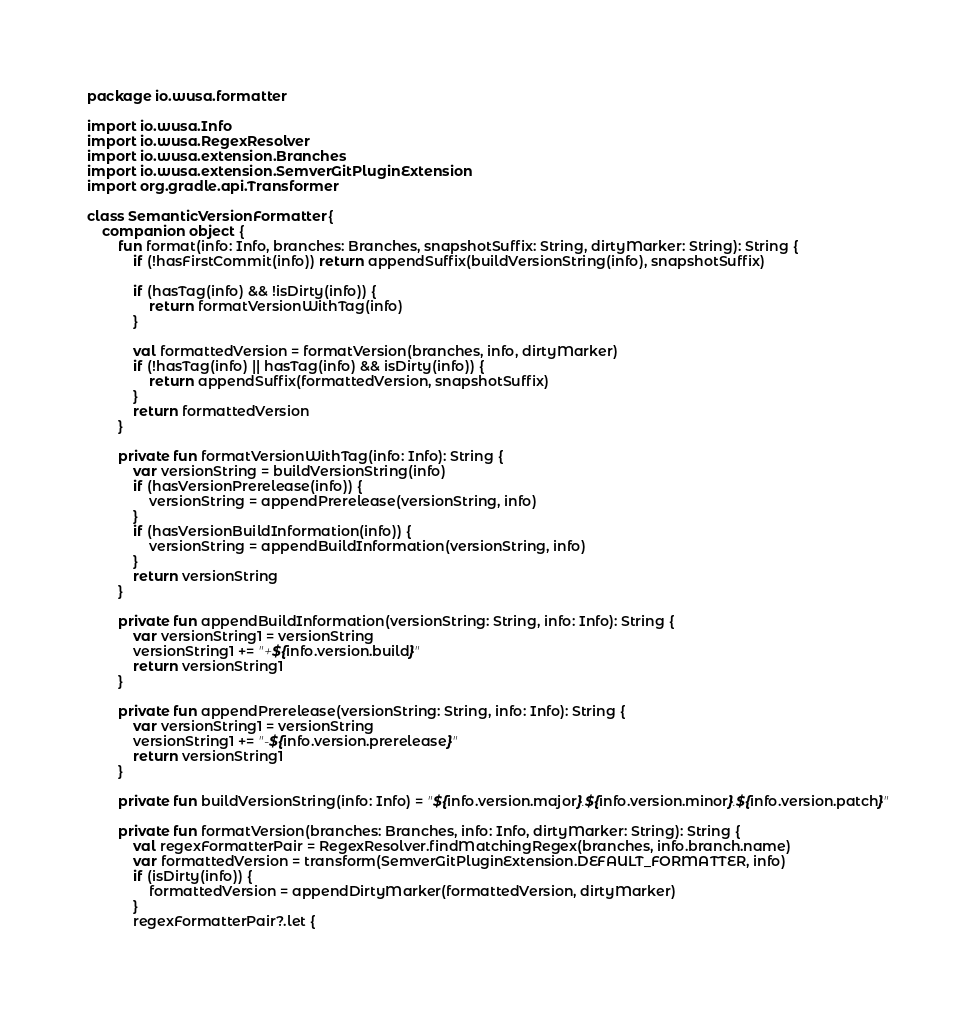Convert code to text. <code><loc_0><loc_0><loc_500><loc_500><_Kotlin_>package io.wusa.formatter

import io.wusa.Info
import io.wusa.RegexResolver
import io.wusa.extension.Branches
import io.wusa.extension.SemverGitPluginExtension
import org.gradle.api.Transformer

class SemanticVersionFormatter {
    companion object {
        fun format(info: Info, branches: Branches, snapshotSuffix: String, dirtyMarker: String): String {
            if (!hasFirstCommit(info)) return appendSuffix(buildVersionString(info), snapshotSuffix)

            if (hasTag(info) && !isDirty(info)) {
                return formatVersionWithTag(info)
            }

            val formattedVersion = formatVersion(branches, info, dirtyMarker)
            if (!hasTag(info) || hasTag(info) && isDirty(info)) {
                return appendSuffix(formattedVersion, snapshotSuffix)
            }
            return formattedVersion
        }

        private fun formatVersionWithTag(info: Info): String {
            var versionString = buildVersionString(info)
            if (hasVersionPrerelease(info)) {
                versionString = appendPrerelease(versionString, info)
            }
            if (hasVersionBuildInformation(info)) {
                versionString = appendBuildInformation(versionString, info)
            }
            return versionString
        }

        private fun appendBuildInformation(versionString: String, info: Info): String {
            var versionString1 = versionString
            versionString1 += "+${info.version.build}"
            return versionString1
        }

        private fun appendPrerelease(versionString: String, info: Info): String {
            var versionString1 = versionString
            versionString1 += "-${info.version.prerelease}"
            return versionString1
        }

        private fun buildVersionString(info: Info) = "${info.version.major}.${info.version.minor}.${info.version.patch}"

        private fun formatVersion(branches: Branches, info: Info, dirtyMarker: String): String {
            val regexFormatterPair = RegexResolver.findMatchingRegex(branches, info.branch.name)
            var formattedVersion = transform(SemverGitPluginExtension.DEFAULT_FORMATTER, info)
            if (isDirty(info)) {
                formattedVersion = appendDirtyMarker(formattedVersion, dirtyMarker)
            }
            regexFormatterPair?.let {</code> 